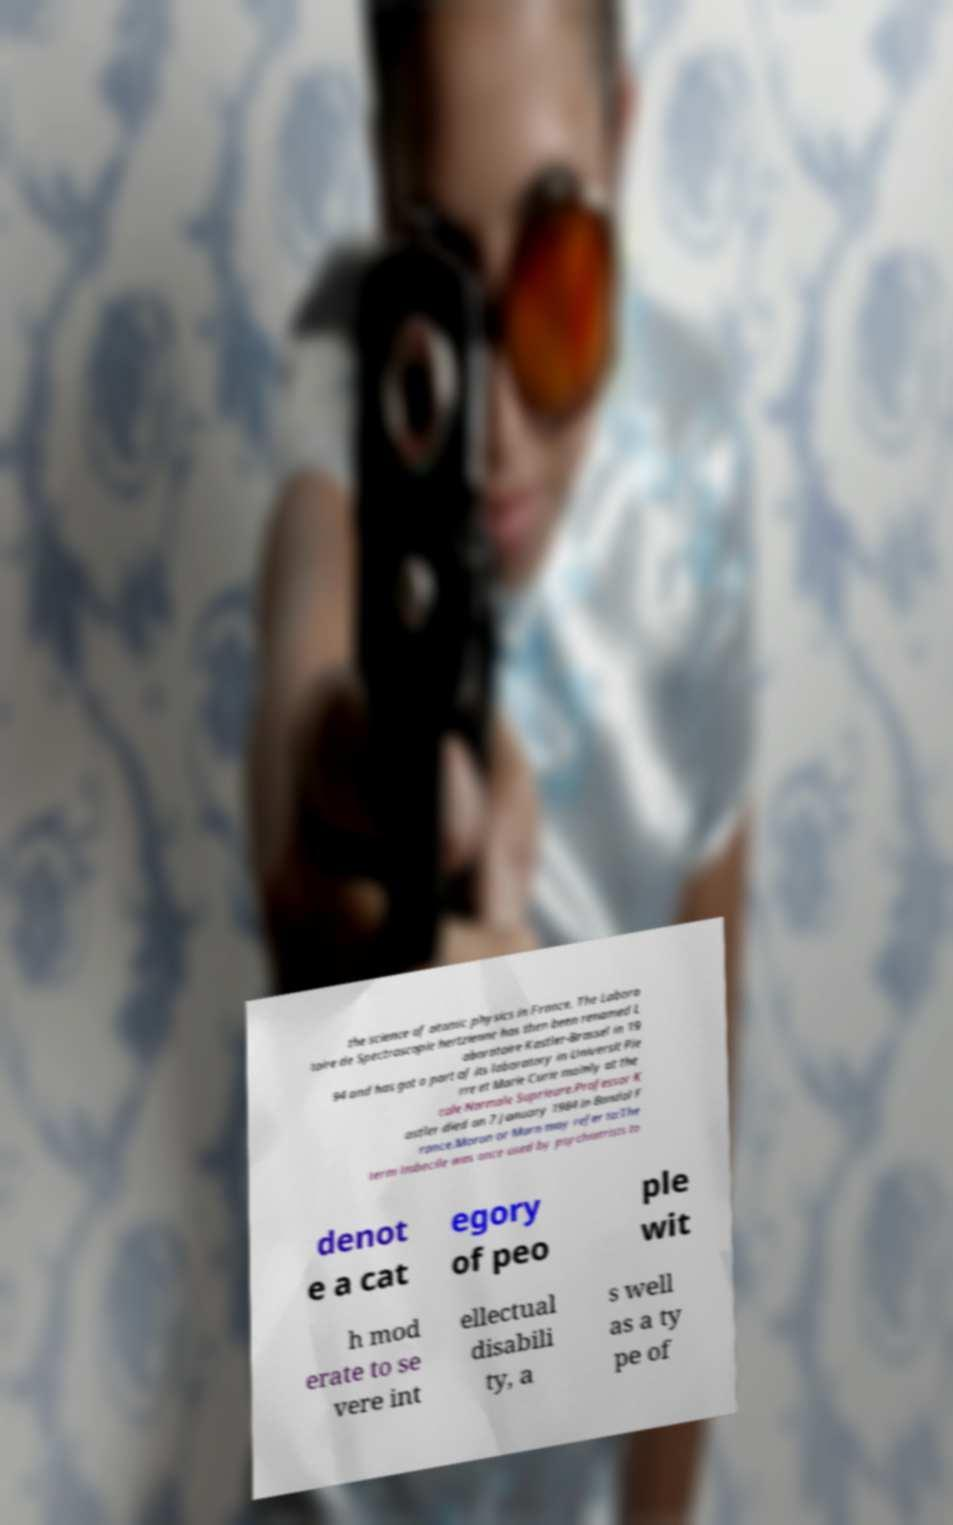I need the written content from this picture converted into text. Can you do that? the science of atomic physics in France. The Labora toire de Spectroscopie hertzienne has then been renamed L aboratoire Kastler-Brossel in 19 94 and has got a part of its laboratory in Universit Pie rre et Marie Curie mainly at the cole Normale Suprieure.Professor K astler died on 7 January 1984 in Bandol F rance.Moron or Morn may refer to:The term imbecile was once used by psychiatrists to denot e a cat egory of peo ple wit h mod erate to se vere int ellectual disabili ty, a s well as a ty pe of 